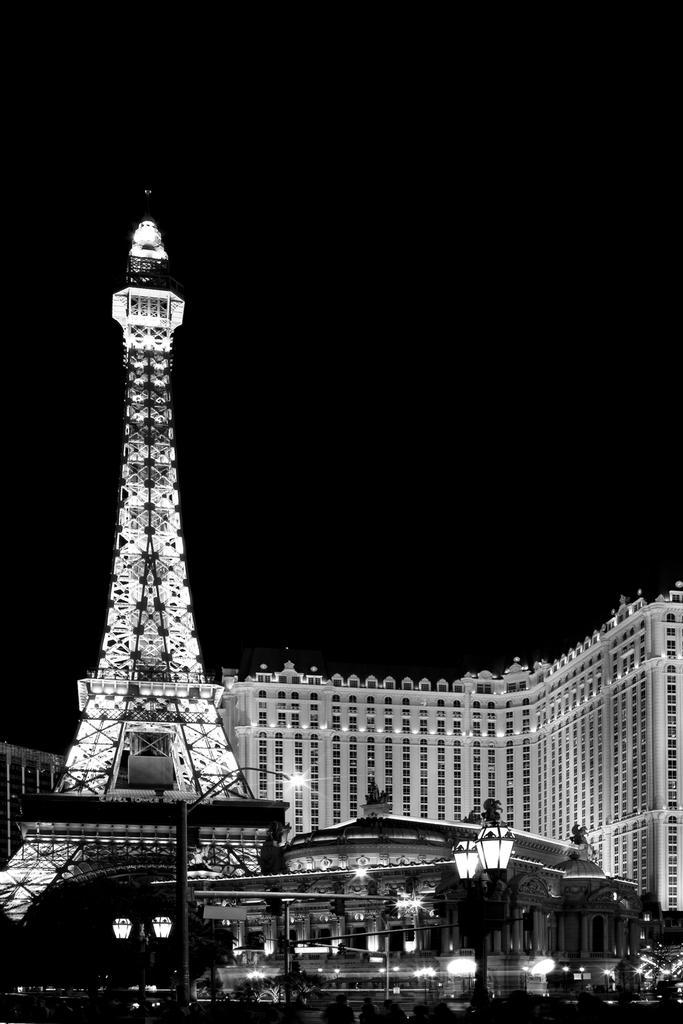How would you summarize this image in a sentence or two? It looks like a black and white image. I can see an Eiffel tower and the buildings with the lights. At the bottom of the image, I can see the light poles. The background looks dark. 